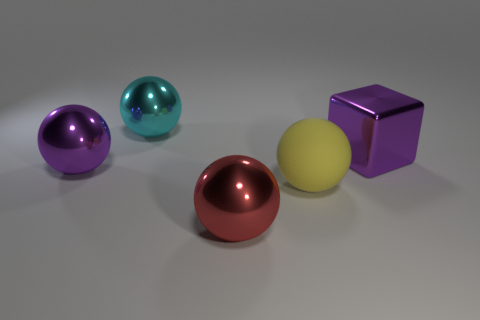What might be the purpose of this arrangement or what does it convey? This composition could be for aesthetically pleasing product display or a 3D rendering showcasing different-colored objects and how they interact with light, providing a clear demonstration of color, reflection, and shadow.  How do the colors of the objects affect the mood or feeling of the image? The vibrant and contrasting colors of the spheres, along with the muted background, create a visually intriguing scene. The colors can evoke a sense of playfulness and modernity, and the precise arrangement gives off a feeling of order and cleanliness. 